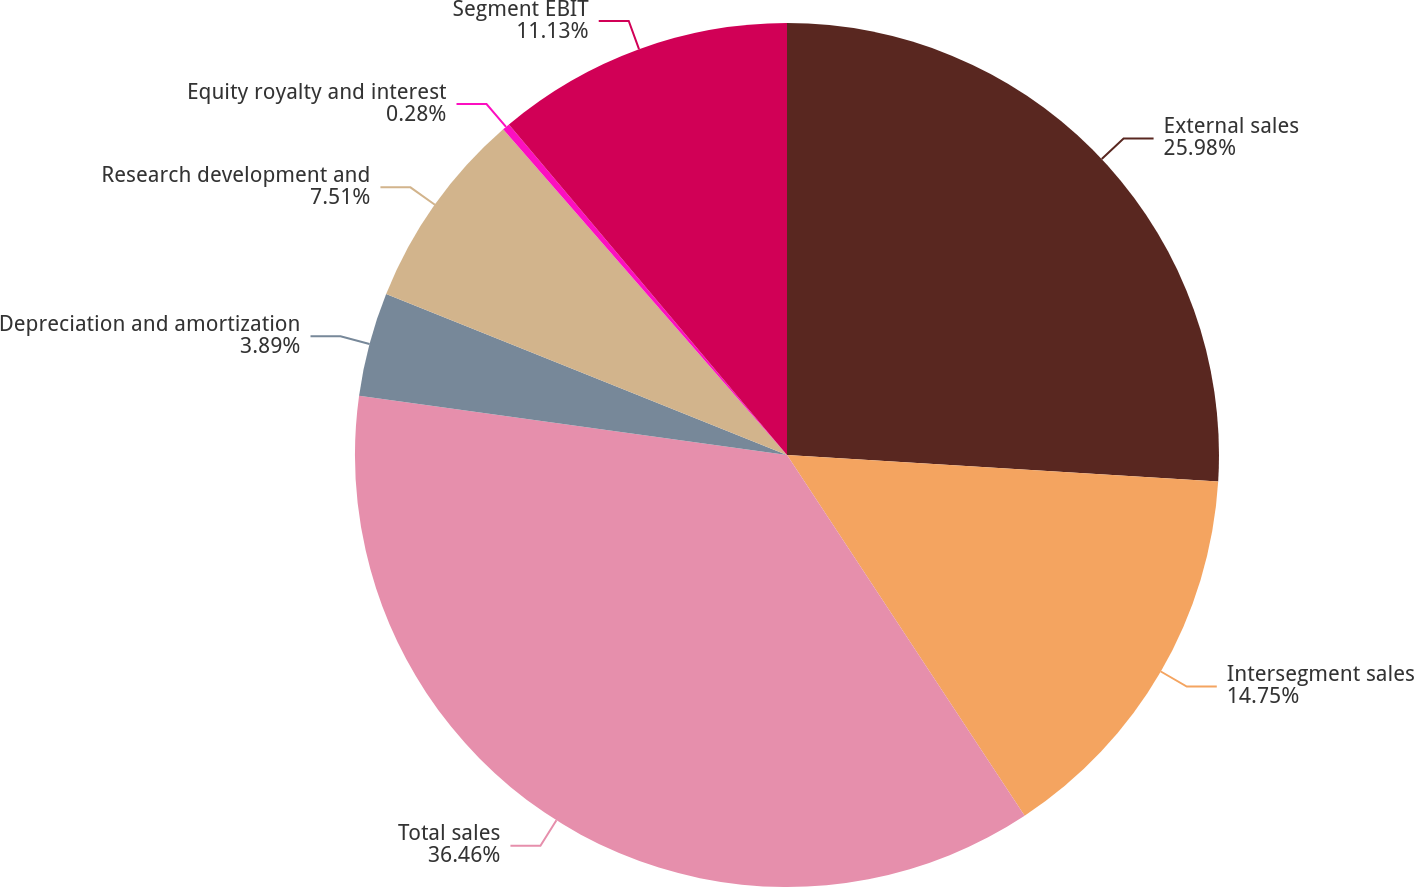<chart> <loc_0><loc_0><loc_500><loc_500><pie_chart><fcel>External sales<fcel>Intersegment sales<fcel>Total sales<fcel>Depreciation and amortization<fcel>Research development and<fcel>Equity royalty and interest<fcel>Segment EBIT<nl><fcel>25.98%<fcel>14.75%<fcel>36.46%<fcel>3.89%<fcel>7.51%<fcel>0.28%<fcel>11.13%<nl></chart> 